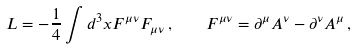<formula> <loc_0><loc_0><loc_500><loc_500>L = - \frac { 1 } { 4 } \int d ^ { 3 } x F ^ { \mu \nu } F _ { \mu \nu } \, , \quad F ^ { \mu \nu } = \partial ^ { \mu } A ^ { \nu } - \partial ^ { \nu } A ^ { \mu } \, ,</formula> 